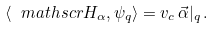Convert formula to latex. <formula><loc_0><loc_0><loc_500><loc_500>\langle \ m a t h s c r { H } _ { \alpha } , \psi _ { q } \rangle = v _ { c } \, \vec { \alpha } | _ { q } \, .</formula> 